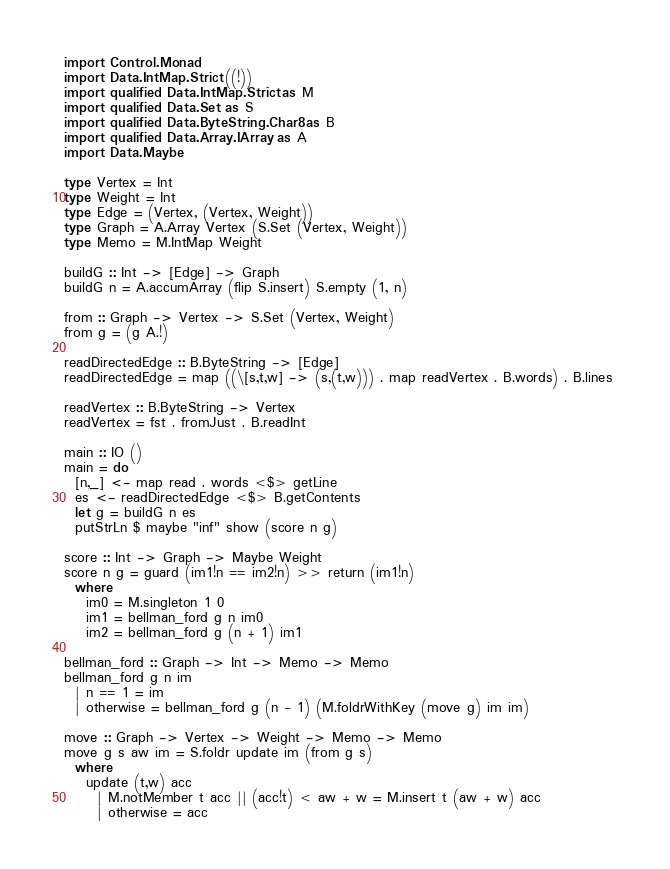Convert code to text. <code><loc_0><loc_0><loc_500><loc_500><_Haskell_>import Control.Monad
import Data.IntMap.Strict ((!)) 
import qualified Data.IntMap.Strict as M 
import qualified Data.Set as S 
import qualified Data.ByteString.Char8 as B 
import qualified Data.Array.IArray as A 
import Data.Maybe 

type Vertex = Int 
type Weight = Int 
type Edge = (Vertex, (Vertex, Weight)) 
type Graph = A.Array Vertex (S.Set (Vertex, Weight))
type Memo = M.IntMap Weight

buildG :: Int -> [Edge] -> Graph 
buildG n = A.accumArray (flip S.insert) S.empty (1, n) 

from :: Graph -> Vertex -> S.Set (Vertex, Weight) 
from g = (g A.!) 

readDirectedEdge :: B.ByteString -> [Edge] 
readDirectedEdge = map ((\[s,t,w] -> (s,(t,w))) . map readVertex . B.words) . B.lines 

readVertex :: B.ByteString -> Vertex 
readVertex = fst . fromJust . B.readInt

main :: IO ()
main = do
  [n,_] <- map read . words <$> getLine
  es <- readDirectedEdge <$> B.getContents
  let g = buildG n es
  putStrLn $ maybe "inf" show (score n g)

score :: Int -> Graph -> Maybe Weight
score n g = guard (im1!n == im2!n) >> return (im1!n)
  where
    im0 = M.singleton 1 0
    im1 = bellman_ford g n im0
    im2 = bellman_ford g (n + 1) im1

bellman_ford :: Graph -> Int -> Memo -> Memo
bellman_ford g n im
  | n == 1 = im
  | otherwise = bellman_ford g (n - 1) (M.foldrWithKey (move g) im im)

move :: Graph -> Vertex -> Weight -> Memo -> Memo
move g s aw im = S.foldr update im (from g s)
  where 
    update (t,w) acc
      | M.notMember t acc || (acc!t) < aw + w = M.insert t (aw + w) acc
      | otherwise = acc</code> 